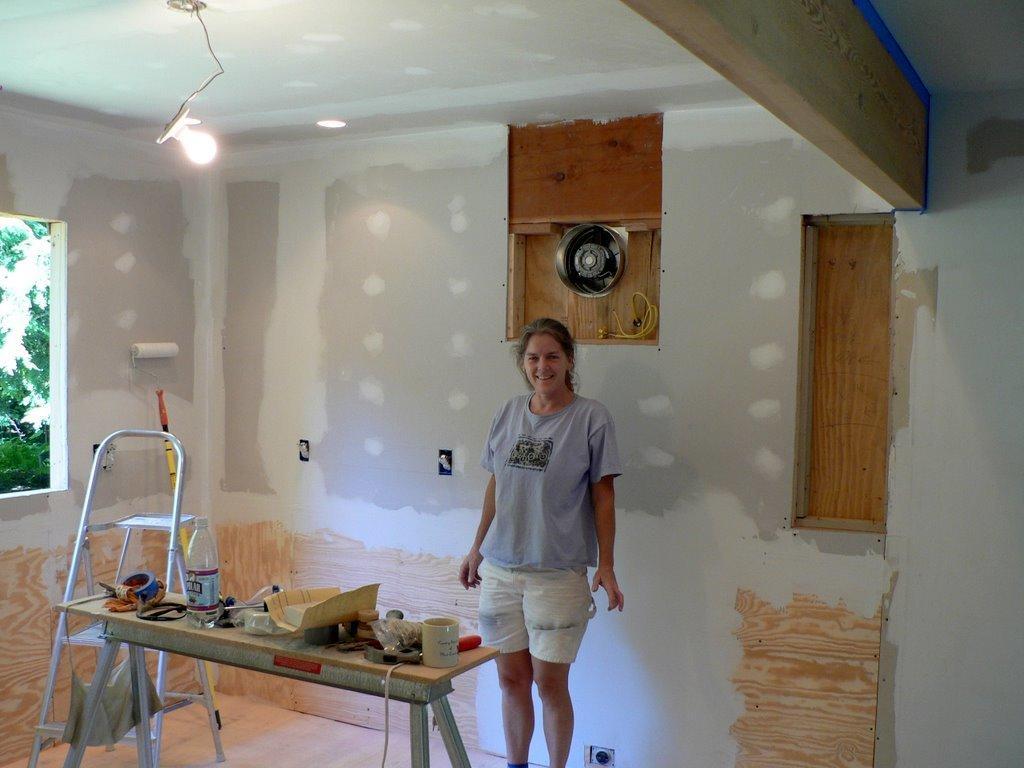In one or two sentences, can you explain what this image depicts? This picture is taken inside a room. There is a woman standing. In front of her there is a table and ladder. On the table there is bottle, cap, paper, cloth and many other things. There is bulb hanging to the ceiling. To the left corner there is window and plants can be seen. In the background there is wall. 